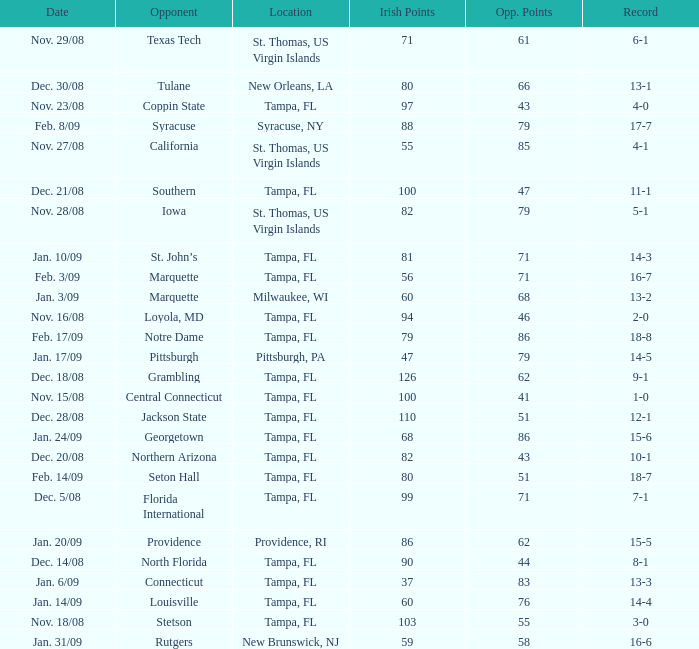What is the number of opponents where the location is syracuse, ny? 1.0. 